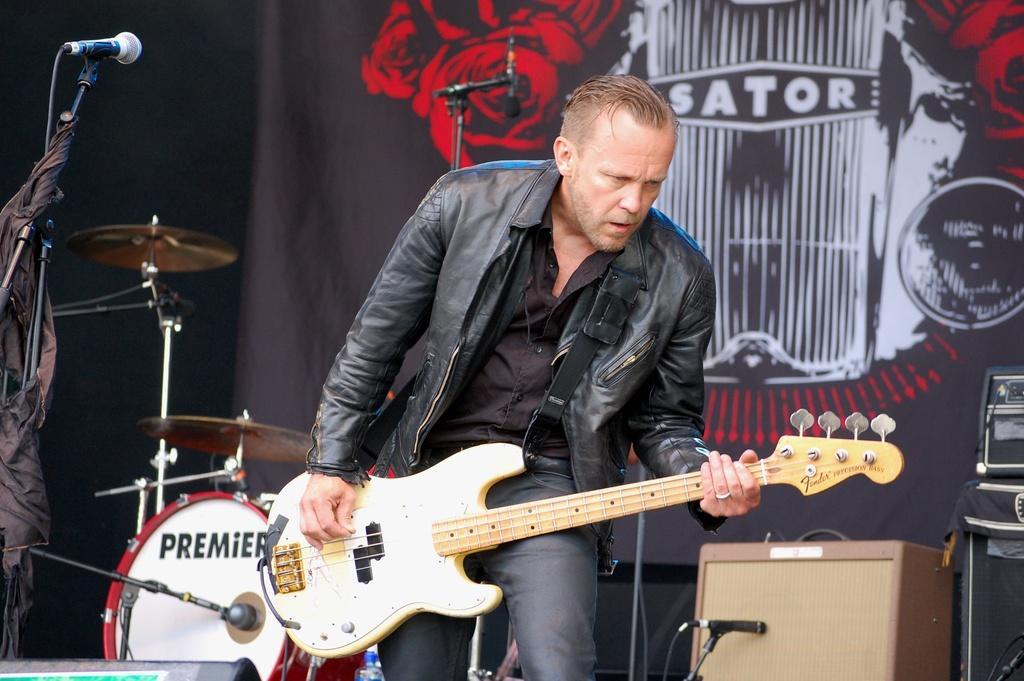In one or two sentences, can you explain what this image depicts? In this image I see a man who is standing and holding a guitar and I see that he is wearing a jacket. I can also see there is a mic over here. In the background I see a musical instrument, few equipment and another mac over here. 